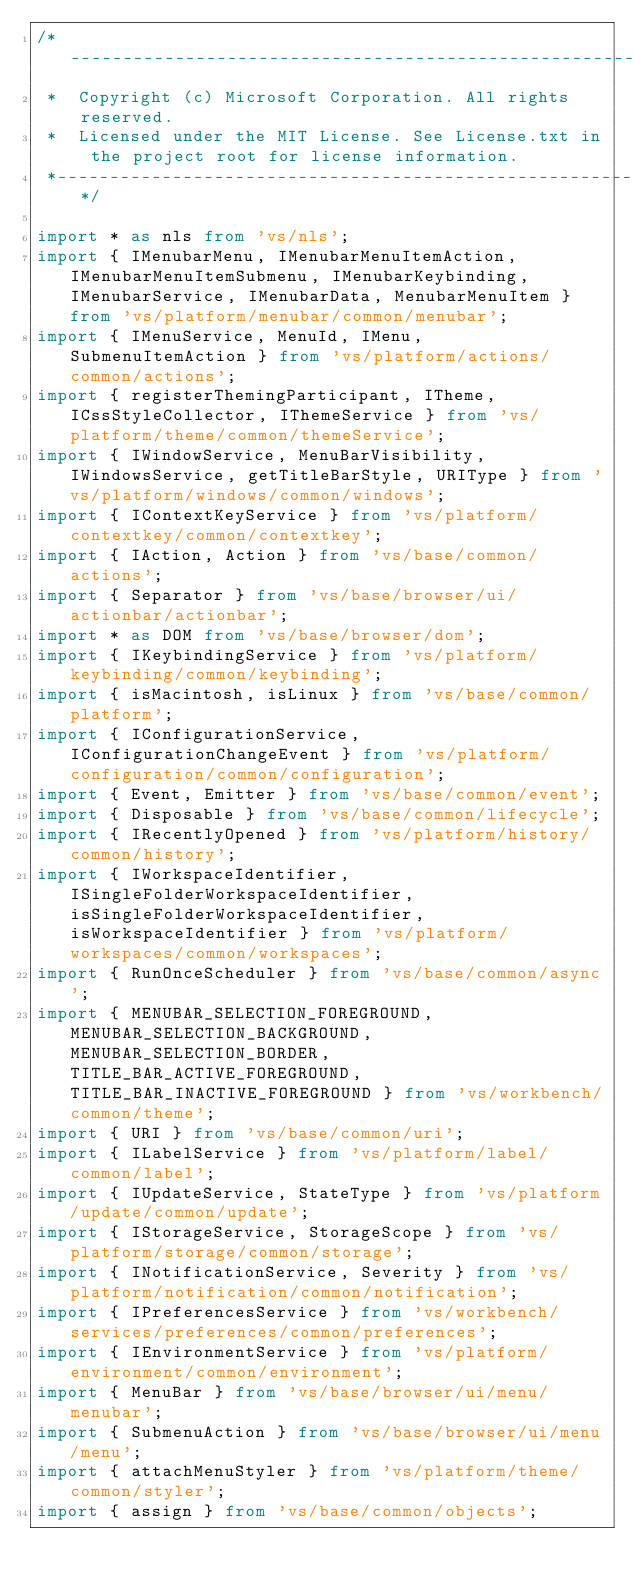Convert code to text. <code><loc_0><loc_0><loc_500><loc_500><_TypeScript_>/*---------------------------------------------------------------------------------------------
 *  Copyright (c) Microsoft Corporation. All rights reserved.
 *  Licensed under the MIT License. See License.txt in the project root for license information.
 *--------------------------------------------------------------------------------------------*/

import * as nls from 'vs/nls';
import { IMenubarMenu, IMenubarMenuItemAction, IMenubarMenuItemSubmenu, IMenubarKeybinding, IMenubarService, IMenubarData, MenubarMenuItem } from 'vs/platform/menubar/common/menubar';
import { IMenuService, MenuId, IMenu, SubmenuItemAction } from 'vs/platform/actions/common/actions';
import { registerThemingParticipant, ITheme, ICssStyleCollector, IThemeService } from 'vs/platform/theme/common/themeService';
import { IWindowService, MenuBarVisibility, IWindowsService, getTitleBarStyle, URIType } from 'vs/platform/windows/common/windows';
import { IContextKeyService } from 'vs/platform/contextkey/common/contextkey';
import { IAction, Action } from 'vs/base/common/actions';
import { Separator } from 'vs/base/browser/ui/actionbar/actionbar';
import * as DOM from 'vs/base/browser/dom';
import { IKeybindingService } from 'vs/platform/keybinding/common/keybinding';
import { isMacintosh, isLinux } from 'vs/base/common/platform';
import { IConfigurationService, IConfigurationChangeEvent } from 'vs/platform/configuration/common/configuration';
import { Event, Emitter } from 'vs/base/common/event';
import { Disposable } from 'vs/base/common/lifecycle';
import { IRecentlyOpened } from 'vs/platform/history/common/history';
import { IWorkspaceIdentifier, ISingleFolderWorkspaceIdentifier, isSingleFolderWorkspaceIdentifier, isWorkspaceIdentifier } from 'vs/platform/workspaces/common/workspaces';
import { RunOnceScheduler } from 'vs/base/common/async';
import { MENUBAR_SELECTION_FOREGROUND, MENUBAR_SELECTION_BACKGROUND, MENUBAR_SELECTION_BORDER, TITLE_BAR_ACTIVE_FOREGROUND, TITLE_BAR_INACTIVE_FOREGROUND } from 'vs/workbench/common/theme';
import { URI } from 'vs/base/common/uri';
import { ILabelService } from 'vs/platform/label/common/label';
import { IUpdateService, StateType } from 'vs/platform/update/common/update';
import { IStorageService, StorageScope } from 'vs/platform/storage/common/storage';
import { INotificationService, Severity } from 'vs/platform/notification/common/notification';
import { IPreferencesService } from 'vs/workbench/services/preferences/common/preferences';
import { IEnvironmentService } from 'vs/platform/environment/common/environment';
import { MenuBar } from 'vs/base/browser/ui/menu/menubar';
import { SubmenuAction } from 'vs/base/browser/ui/menu/menu';
import { attachMenuStyler } from 'vs/platform/theme/common/styler';
import { assign } from 'vs/base/common/objects';</code> 